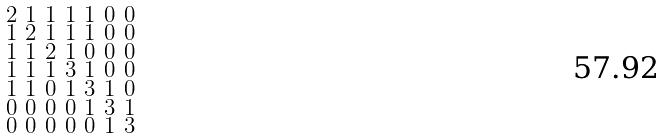<formula> <loc_0><loc_0><loc_500><loc_500>\begin{smallmatrix} 2 & 1 & 1 & 1 & 1 & 0 & 0 \\ 1 & 2 & 1 & 1 & 1 & 0 & 0 \\ 1 & 1 & 2 & 1 & 0 & 0 & 0 \\ 1 & 1 & 1 & 3 & 1 & 0 & 0 \\ 1 & 1 & 0 & 1 & 3 & 1 & 0 \\ 0 & 0 & 0 & 0 & 1 & 3 & 1 \\ 0 & 0 & 0 & 0 & 0 & 1 & 3 \end{smallmatrix}</formula> 